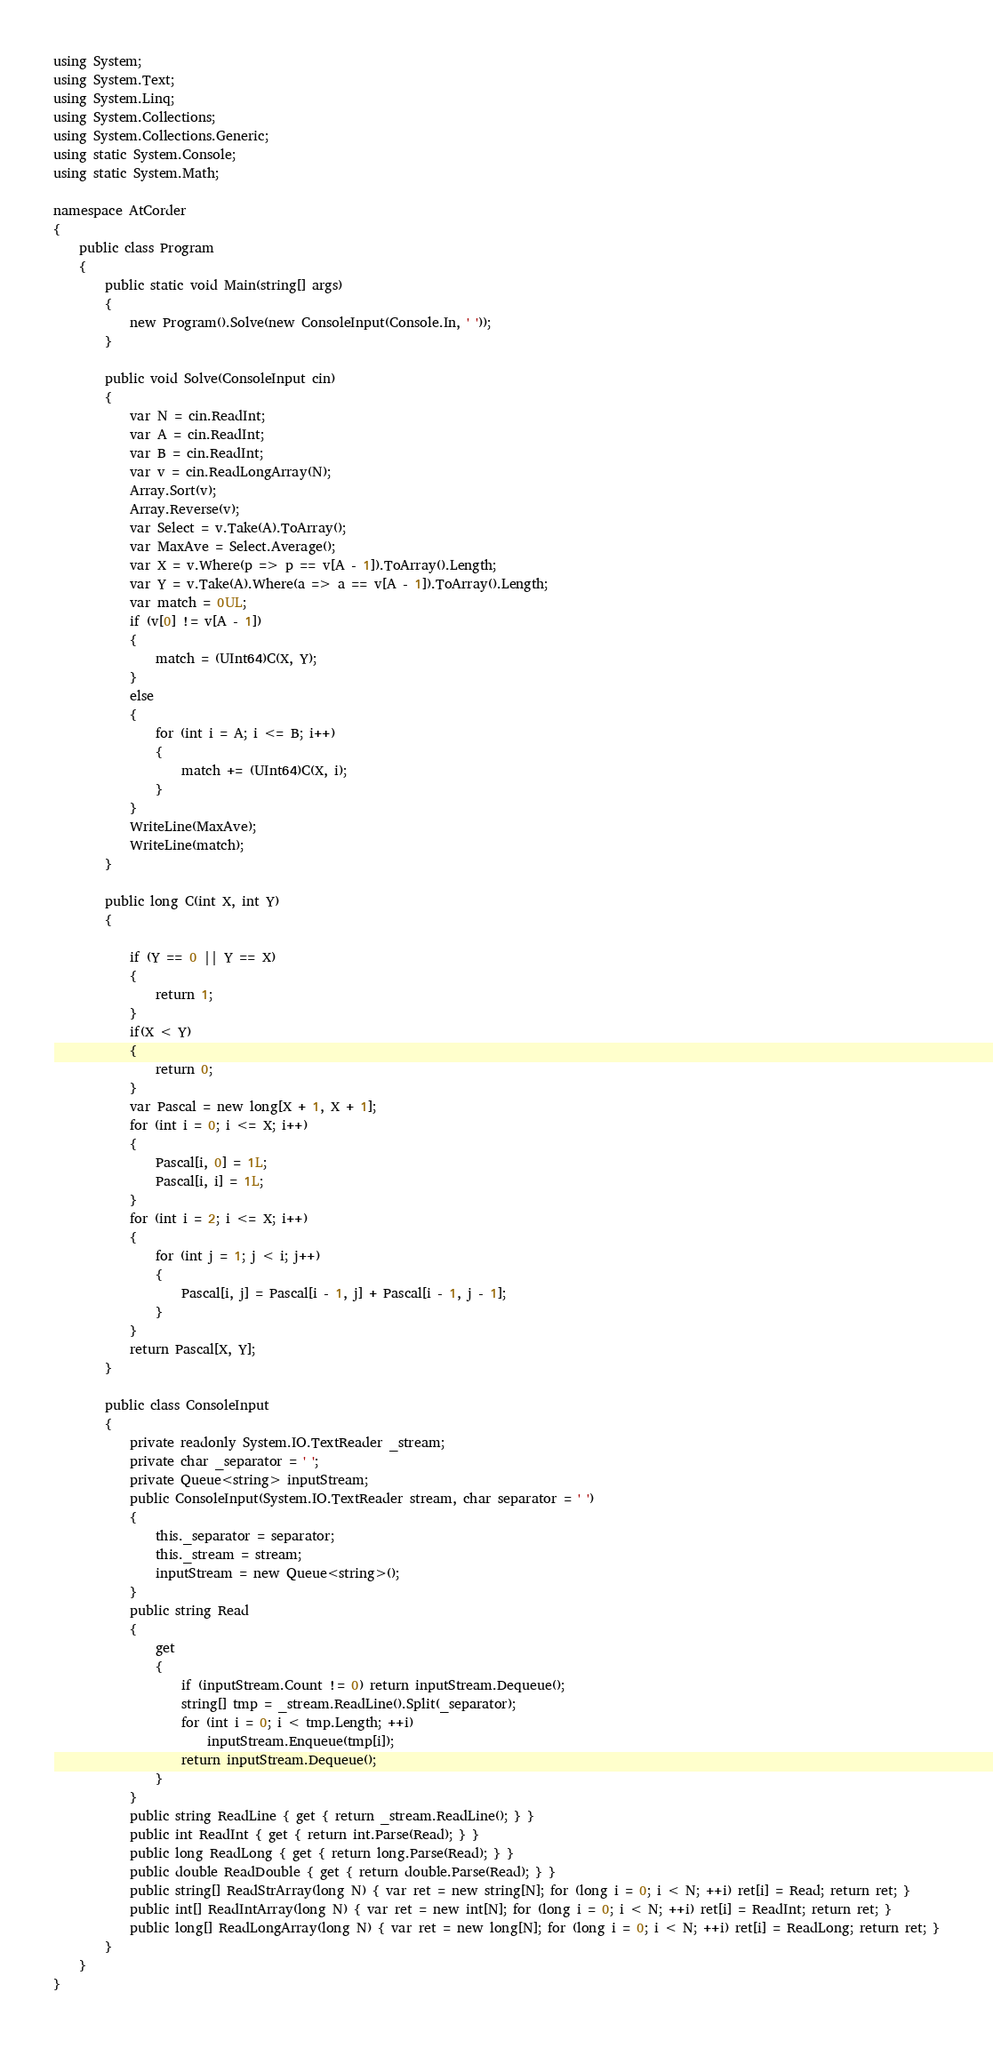Convert code to text. <code><loc_0><loc_0><loc_500><loc_500><_C#_>using System;
using System.Text;
using System.Linq;
using System.Collections;
using System.Collections.Generic;
using static System.Console;
using static System.Math;

namespace AtCorder
{
    public class Program
    {
        public static void Main(string[] args)
        {
            new Program().Solve(new ConsoleInput(Console.In, ' '));
        }

        public void Solve(ConsoleInput cin)
        {
            var N = cin.ReadInt;
            var A = cin.ReadInt;
            var B = cin.ReadInt;
            var v = cin.ReadLongArray(N);
            Array.Sort(v);
            Array.Reverse(v);
            var Select = v.Take(A).ToArray();
            var MaxAve = Select.Average();
            var X = v.Where(p => p == v[A - 1]).ToArray().Length;
            var Y = v.Take(A).Where(a => a == v[A - 1]).ToArray().Length;
            var match = 0UL;
            if (v[0] != v[A - 1])
            {
                match = (UInt64)C(X, Y);
            }
            else
            {
                for (int i = A; i <= B; i++)
                {
                    match += (UInt64)C(X, i);
                }
            }
            WriteLine(MaxAve);
            WriteLine(match);
        }

        public long C(int X, int Y)
        {

            if (Y == 0 || Y == X)
            {
                return 1;
            }
            if(X < Y)
            {
                return 0;
            }
            var Pascal = new long[X + 1, X + 1];
            for (int i = 0; i <= X; i++)
            {
                Pascal[i, 0] = 1L;
                Pascal[i, i] = 1L;
            }
            for (int i = 2; i <= X; i++)
            {
                for (int j = 1; j < i; j++)
                {
                    Pascal[i, j] = Pascal[i - 1, j] + Pascal[i - 1, j - 1];
                }
            }
            return Pascal[X, Y];
        }

        public class ConsoleInput
        {
            private readonly System.IO.TextReader _stream;
            private char _separator = ' ';
            private Queue<string> inputStream;
            public ConsoleInput(System.IO.TextReader stream, char separator = ' ')
            {
                this._separator = separator;
                this._stream = stream;
                inputStream = new Queue<string>();
            }
            public string Read
            {
                get
                {
                    if (inputStream.Count != 0) return inputStream.Dequeue();
                    string[] tmp = _stream.ReadLine().Split(_separator);
                    for (int i = 0; i < tmp.Length; ++i)
                        inputStream.Enqueue(tmp[i]);
                    return inputStream.Dequeue();
                }
            }
            public string ReadLine { get { return _stream.ReadLine(); } }
            public int ReadInt { get { return int.Parse(Read); } }
            public long ReadLong { get { return long.Parse(Read); } }
            public double ReadDouble { get { return double.Parse(Read); } }
            public string[] ReadStrArray(long N) { var ret = new string[N]; for (long i = 0; i < N; ++i) ret[i] = Read; return ret; }
            public int[] ReadIntArray(long N) { var ret = new int[N]; for (long i = 0; i < N; ++i) ret[i] = ReadInt; return ret; }
            public long[] ReadLongArray(long N) { var ret = new long[N]; for (long i = 0; i < N; ++i) ret[i] = ReadLong; return ret; }
        }
    }
}
</code> 